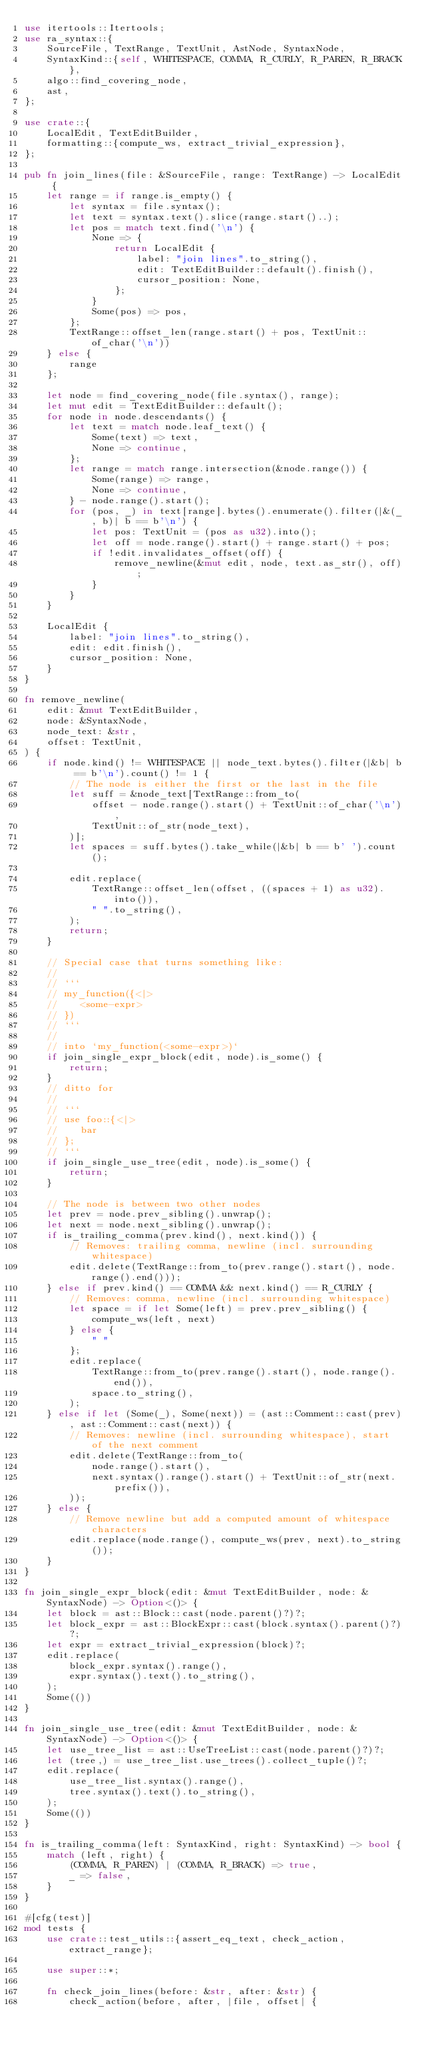<code> <loc_0><loc_0><loc_500><loc_500><_Rust_>use itertools::Itertools;
use ra_syntax::{
    SourceFile, TextRange, TextUnit, AstNode, SyntaxNode,
    SyntaxKind::{self, WHITESPACE, COMMA, R_CURLY, R_PAREN, R_BRACK},
    algo::find_covering_node,
    ast,
};

use crate::{
    LocalEdit, TextEditBuilder,
    formatting::{compute_ws, extract_trivial_expression},
};

pub fn join_lines(file: &SourceFile, range: TextRange) -> LocalEdit {
    let range = if range.is_empty() {
        let syntax = file.syntax();
        let text = syntax.text().slice(range.start()..);
        let pos = match text.find('\n') {
            None => {
                return LocalEdit {
                    label: "join lines".to_string(),
                    edit: TextEditBuilder::default().finish(),
                    cursor_position: None,
                };
            }
            Some(pos) => pos,
        };
        TextRange::offset_len(range.start() + pos, TextUnit::of_char('\n'))
    } else {
        range
    };

    let node = find_covering_node(file.syntax(), range);
    let mut edit = TextEditBuilder::default();
    for node in node.descendants() {
        let text = match node.leaf_text() {
            Some(text) => text,
            None => continue,
        };
        let range = match range.intersection(&node.range()) {
            Some(range) => range,
            None => continue,
        } - node.range().start();
        for (pos, _) in text[range].bytes().enumerate().filter(|&(_, b)| b == b'\n') {
            let pos: TextUnit = (pos as u32).into();
            let off = node.range().start() + range.start() + pos;
            if !edit.invalidates_offset(off) {
                remove_newline(&mut edit, node, text.as_str(), off);
            }
        }
    }

    LocalEdit {
        label: "join lines".to_string(),
        edit: edit.finish(),
        cursor_position: None,
    }
}

fn remove_newline(
    edit: &mut TextEditBuilder,
    node: &SyntaxNode,
    node_text: &str,
    offset: TextUnit,
) {
    if node.kind() != WHITESPACE || node_text.bytes().filter(|&b| b == b'\n').count() != 1 {
        // The node is either the first or the last in the file
        let suff = &node_text[TextRange::from_to(
            offset - node.range().start() + TextUnit::of_char('\n'),
            TextUnit::of_str(node_text),
        )];
        let spaces = suff.bytes().take_while(|&b| b == b' ').count();

        edit.replace(
            TextRange::offset_len(offset, ((spaces + 1) as u32).into()),
            " ".to_string(),
        );
        return;
    }

    // Special case that turns something like:
    //
    // ```
    // my_function({<|>
    //    <some-expr>
    // })
    // ```
    //
    // into `my_function(<some-expr>)`
    if join_single_expr_block(edit, node).is_some() {
        return;
    }
    // ditto for
    //
    // ```
    // use foo::{<|>
    //    bar
    // };
    // ```
    if join_single_use_tree(edit, node).is_some() {
        return;
    }

    // The node is between two other nodes
    let prev = node.prev_sibling().unwrap();
    let next = node.next_sibling().unwrap();
    if is_trailing_comma(prev.kind(), next.kind()) {
        // Removes: trailing comma, newline (incl. surrounding whitespace)
        edit.delete(TextRange::from_to(prev.range().start(), node.range().end()));
    } else if prev.kind() == COMMA && next.kind() == R_CURLY {
        // Removes: comma, newline (incl. surrounding whitespace)
        let space = if let Some(left) = prev.prev_sibling() {
            compute_ws(left, next)
        } else {
            " "
        };
        edit.replace(
            TextRange::from_to(prev.range().start(), node.range().end()),
            space.to_string(),
        );
    } else if let (Some(_), Some(next)) = (ast::Comment::cast(prev), ast::Comment::cast(next)) {
        // Removes: newline (incl. surrounding whitespace), start of the next comment
        edit.delete(TextRange::from_to(
            node.range().start(),
            next.syntax().range().start() + TextUnit::of_str(next.prefix()),
        ));
    } else {
        // Remove newline but add a computed amount of whitespace characters
        edit.replace(node.range(), compute_ws(prev, next).to_string());
    }
}

fn join_single_expr_block(edit: &mut TextEditBuilder, node: &SyntaxNode) -> Option<()> {
    let block = ast::Block::cast(node.parent()?)?;
    let block_expr = ast::BlockExpr::cast(block.syntax().parent()?)?;
    let expr = extract_trivial_expression(block)?;
    edit.replace(
        block_expr.syntax().range(),
        expr.syntax().text().to_string(),
    );
    Some(())
}

fn join_single_use_tree(edit: &mut TextEditBuilder, node: &SyntaxNode) -> Option<()> {
    let use_tree_list = ast::UseTreeList::cast(node.parent()?)?;
    let (tree,) = use_tree_list.use_trees().collect_tuple()?;
    edit.replace(
        use_tree_list.syntax().range(),
        tree.syntax().text().to_string(),
    );
    Some(())
}

fn is_trailing_comma(left: SyntaxKind, right: SyntaxKind) -> bool {
    match (left, right) {
        (COMMA, R_PAREN) | (COMMA, R_BRACK) => true,
        _ => false,
    }
}

#[cfg(test)]
mod tests {
    use crate::test_utils::{assert_eq_text, check_action, extract_range};

    use super::*;

    fn check_join_lines(before: &str, after: &str) {
        check_action(before, after, |file, offset| {</code> 